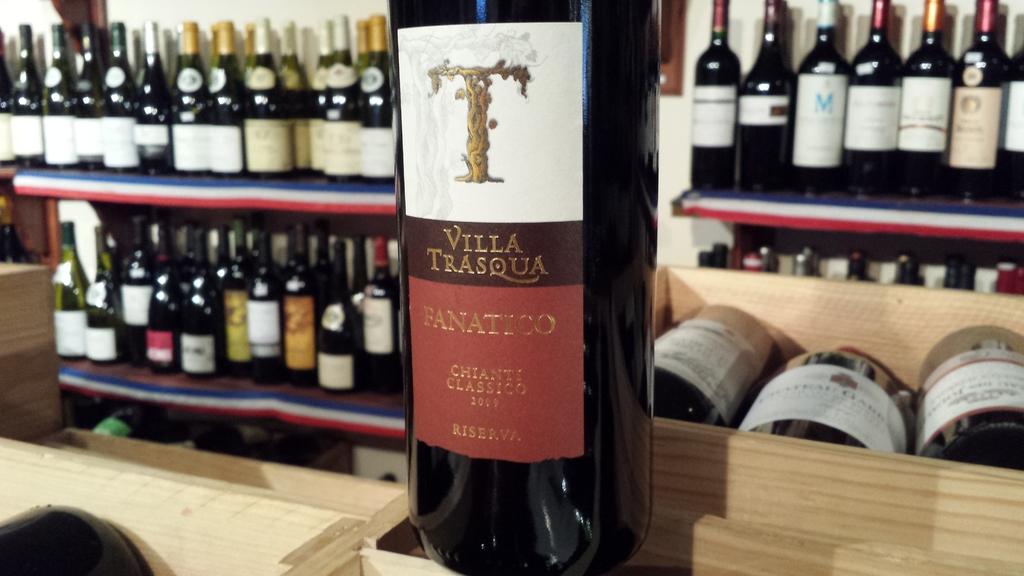What brand of wine?
Make the answer very short. Villa trasqua. 